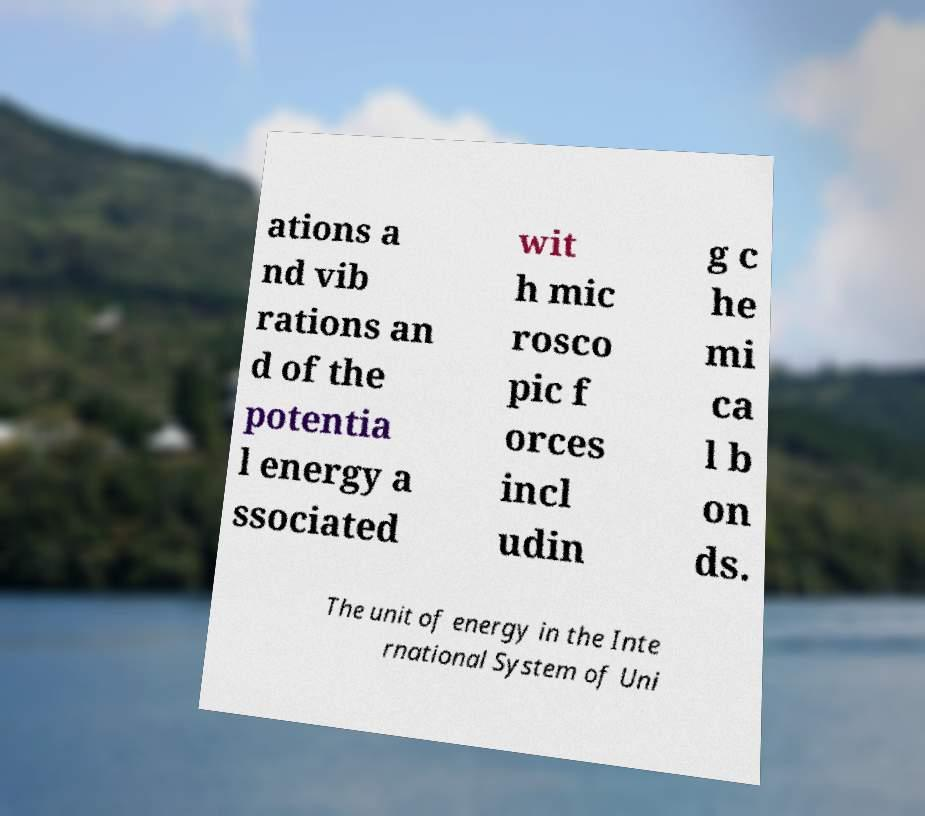Could you extract and type out the text from this image? ations a nd vib rations an d of the potentia l energy a ssociated wit h mic rosco pic f orces incl udin g c he mi ca l b on ds. The unit of energy in the Inte rnational System of Uni 